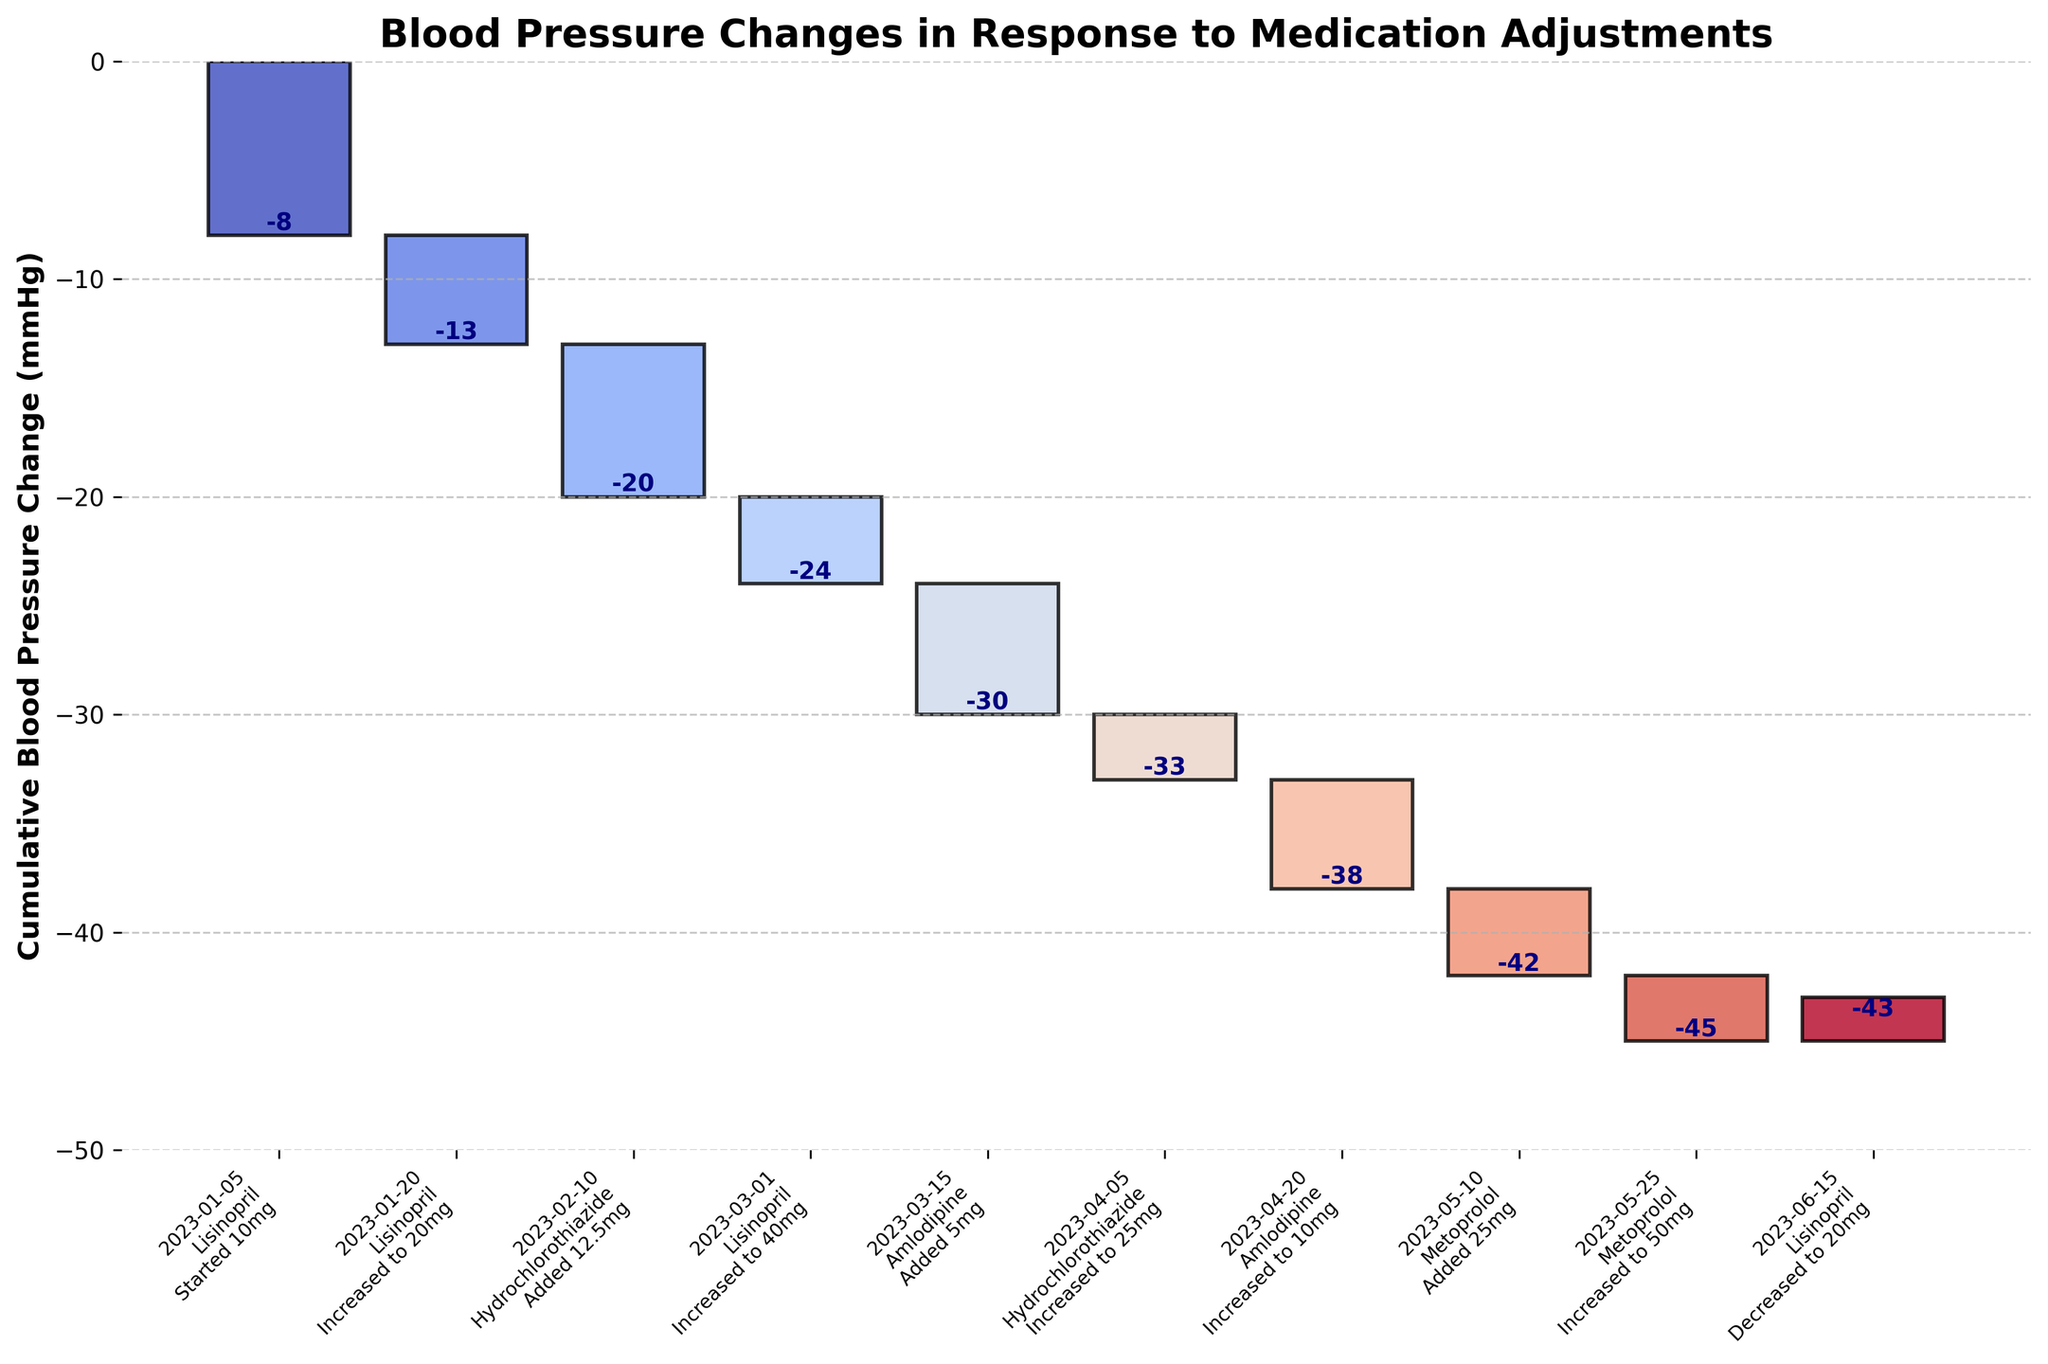What is the title of the chart? The title is located at the top of the figure. By reading it directly, you can identify the title.
Answer: Blood Pressure Changes in Response to Medication Adjustments How many medication changes are shown in the chart? Each bar in the waterfall chart represents a medication change. By counting the bars, we get the total number of changes.
Answer: 10 What is the overall cumulative blood pressure change by the end of the period? The cumulative change is shown at the last bar. By reading the value associated with the last bar, we can get the total cumulative change.
Answer: -43 mmHg Which medication adjustment resulted in the highest decrease in blood pressure? To find this, look for the bar with the largest negative value in the 'BP_Change' column.
Answer: Hydrochlorothiazide (Added 12.5mg) on 2023-02-10 What was the change in blood pressure on 2023-06-15? Locate the date 2023-06-15 on the x-axis. The bar corresponding to this date shows the BP change.
Answer: +2 mmHg What is the difference in cumulative BP change before and after the increase of Amlodipine to 10mg? Identify the cumulative BP change before and after the Amlodipine increase to 10mg (Date: 2023-04-20). Subtract the cumulative BP change just before from the change just after this point. Before: -33, After: -38, Difference = -38 - (-33)
Answer: -5 mmHg Which medication was decreased, and what was the resulting change in BP? Check the 'Change' column for any entry with "Decreased". Then, read the corresponding 'BP_Change' value.
Answer: Lisinopril; +2 mmHg on 2023-06-15 How many times was Lisinopril adjusted during the period, and what was the total BP change attributable to these adjustments? Count the instances of 'Lisinopril' in the 'Medication' column, then sum the 'BP_Change' values for these instances.
Answer: 4 times; -15 mmHg What are the first and last dates shown on the x-axis? Check the x-axis labels for the first and last entries.
Answer: January 5, 2023, and June 15, 2023 What was the BP change when Metoprolol was first introduced? Identify the first instance of 'Metoprolol' in the 'Medication' column, then read the corresponding 'BP_Change' value.
Answer: -4 mmHg on 2023-05-10 